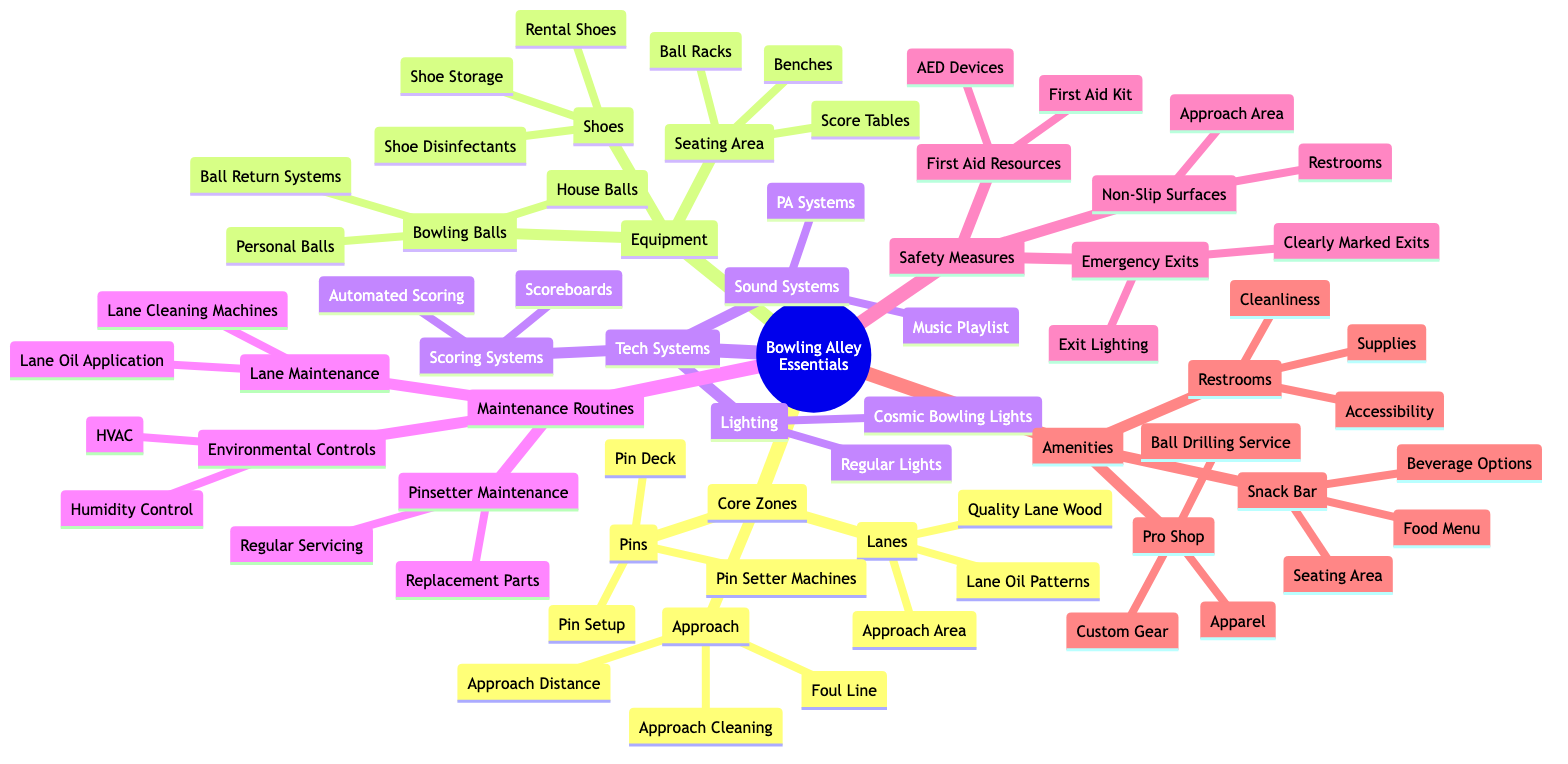What are the three types of items in the Core Zones section? The Core Zones section contains three main categories: Lanes, Pins, and Approach. These represent the essential components of a bowling alley's setup.
Answer: Lanes, Pins, Approach How many items are listed under the Equipment category? The Equipment category has three subcategories: Bowling Balls, Shoes, and Seating Area. Each of these subcategories has further items included. The total listed items are 9 (3 for Bowling Balls, 3 for Shoes, and 3 for Seating Area).
Answer: 9 Which safety measure is designed to prevent slips in the Bowling Alley? The Non-Slip Surfaces measure is specifically designed to reduce the risk of slipping. This is directly related to the approach area and restrooms as mentioned in the diagram.
Answer: Non-Slip Surfaces Name one of the features of the Snack Bar. The Snack Bar has three distinct features listed: Food Menu, Beverage Options, and Seating Area. Any one of these can be considered a feature of the Snack Bar.
Answer: Food Menu What is the main purpose of Lane Maintenance? Lane Maintenance focuses on keeping the bowling lanes in optimal condition. It includes various processes such as cleaning the lanes and applying oil for performance.
Answer: Lane Cleaning Machines How does the maintenance of the Pinsetter relate to the Environmental Controls? The Pinsetter Maintenance involves regular servicing and replacement parts, which ensures that the pinsetter operates efficiently. In contrast, Environmental Controls (like HVAC and Humidity Control) support the overall conditions in which both the lanes and pinsetters function, impacting bowling experiences. Together, they aim to ensure a well-maintained and climate-controlled environment.
Answer: Synergistic Maintenance What role do Automated Scoring systems play in a bowling alley? Automated Scoring systems are responsible for tracking and displaying the scores during bowling games. This increases the efficiency of scorekeeping and enhances the overall bowling experience.
Answer: Tracking Scores Which type of lighting is associated with Cosmic Bowling? The diagram specifies 'Cosmic Bowling Lights' as a unique feature of the Lighting category in Tech Systems. This type of lighting is used typically during special cosmic bowling events for a more fun experience.
Answer: Cosmic Bowling Lights 